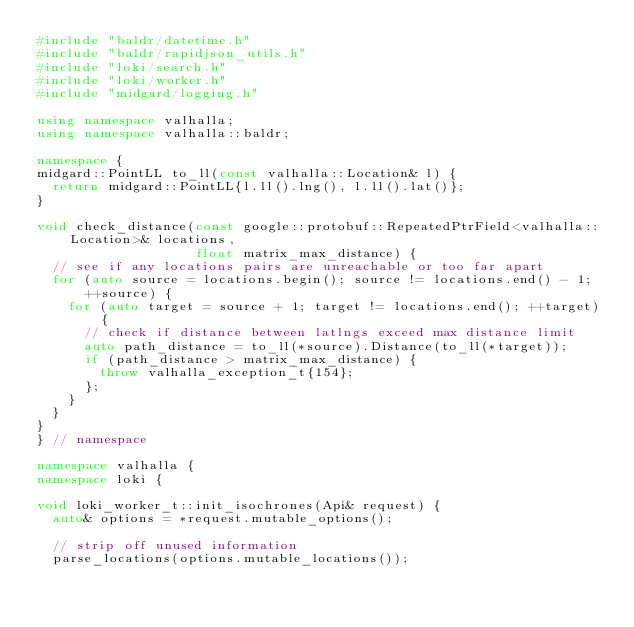<code> <loc_0><loc_0><loc_500><loc_500><_C++_>#include "baldr/datetime.h"
#include "baldr/rapidjson_utils.h"
#include "loki/search.h"
#include "loki/worker.h"
#include "midgard/logging.h"

using namespace valhalla;
using namespace valhalla::baldr;

namespace {
midgard::PointLL to_ll(const valhalla::Location& l) {
  return midgard::PointLL{l.ll().lng(), l.ll().lat()};
}

void check_distance(const google::protobuf::RepeatedPtrField<valhalla::Location>& locations,
                    float matrix_max_distance) {
  // see if any locations pairs are unreachable or too far apart
  for (auto source = locations.begin(); source != locations.end() - 1; ++source) {
    for (auto target = source + 1; target != locations.end(); ++target) {
      // check if distance between latlngs exceed max distance limit
      auto path_distance = to_ll(*source).Distance(to_ll(*target));
      if (path_distance > matrix_max_distance) {
        throw valhalla_exception_t{154};
      };
    }
  }
}
} // namespace

namespace valhalla {
namespace loki {

void loki_worker_t::init_isochrones(Api& request) {
  auto& options = *request.mutable_options();

  // strip off unused information
  parse_locations(options.mutable_locations());</code> 